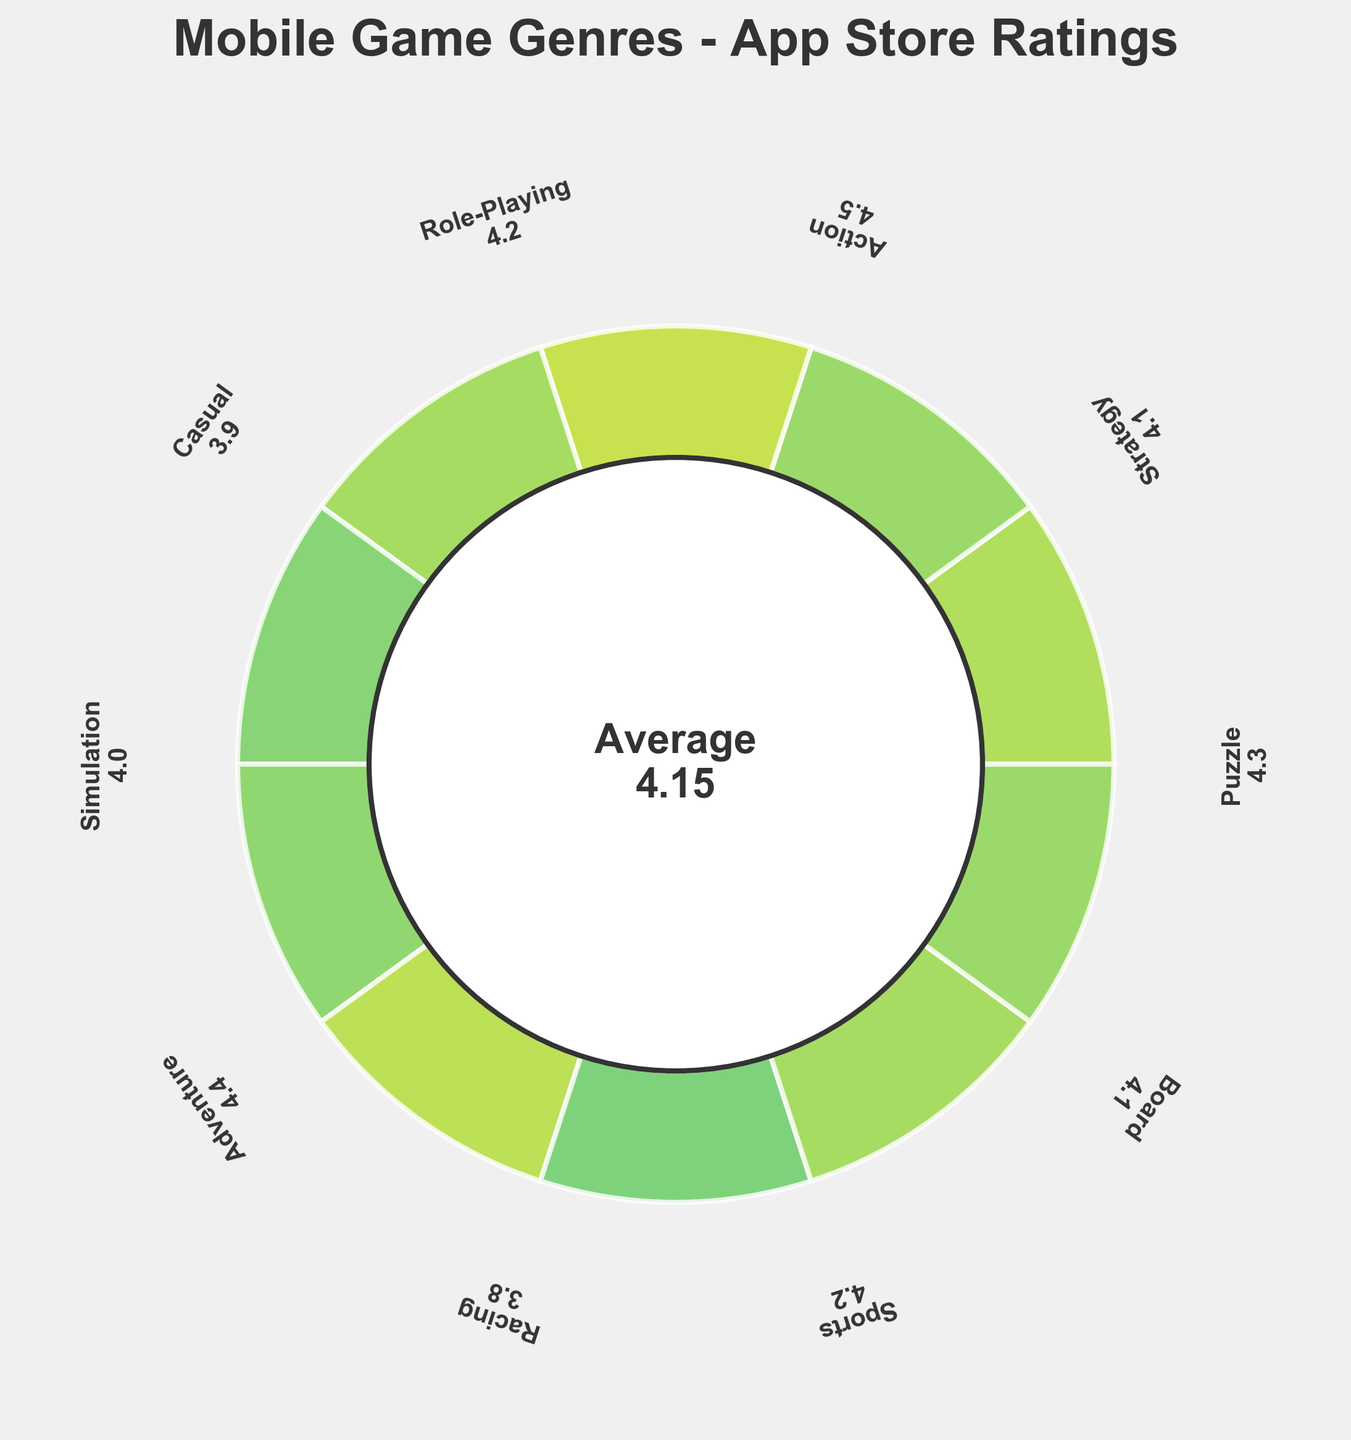What's the title of the plot? The text in the largest font at the top of the figure is usually the title. You can see "Mobile Game Genres - App Store Ratings" clearly at the top of the plot.
Answer: Mobile Game Genres - App Store Ratings How many game genres are displayed in the plot? Count the number of wedges or labels around the circle, where each genre is uniquely represented.
Answer: 10 Which genre has the highest rating? Identify the wedge with the longest reach and the largest numerical label for the rating.
Answer: Action What’s the average rating of all game genres? The average rating is displayed in the center of the plot within the inner circle.
Answer: 4.15 Which genre has the lowest rating? Identify the wedge with the shortest reach and the smallest numerical label for the rating.
Answer: Racing Compare the ratings of Puzzle and Role-Playing genres. Which one is higher? Look at the ratings displayed next to Puzzle and Role-Playing. Puzzle has a rating of 4.3 and Role-Playing has a rating of 4.2. Hence, Puzzle is higher.
Answer: Puzzle What is the color of the wedge representing the Sports genre? Examine the visual color of the wedge labeled as Sports. Since it is encoded by the rating, look for a color near the medium-high range of the colormap.
Answer: Medium-high colored (Viridis colormap) How many genres have a rating above 4.0? Count the number of labels with ratings greater than 4.0 around the circle. These are Puzzle, Strategy, Action, Role-Playing, Adventure, Sports, and Board.
Answer: 7 What is the difference in ratings between the Adventure and Casual genres? Find each rating and subtract one from the other. The rating of Adventure is 4.4 and Casual is 3.9. The difference is 4.4 - 3.9 = 0.5
Answer: 0.5 How do the ratings of Puzzle and Strategy genres compare to the average rating? Compare each genre's rating to the displayed average rating of 4.15. Puzzle (4.3) and Strategy (4.1) relative to 4.15 show that Puzzle is above average, and Strategy is just below average.
Answer: Puzzle above, Strategy below 